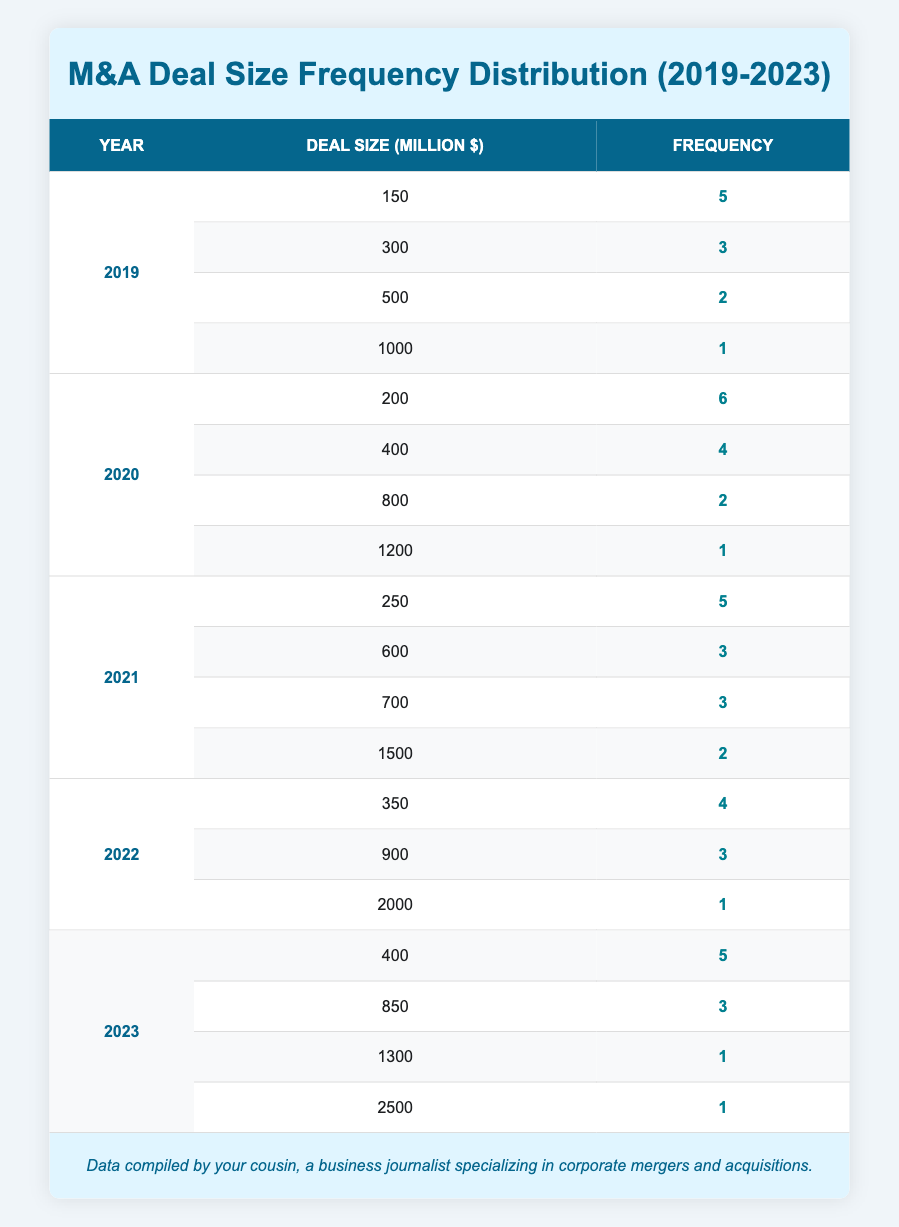What is the total number of M&A transactions in 2019? To find the total number of transactions in 2019, we need to add the counts for each deal size listed for that year. The counts are 5, 3, 2, and 1. So, 5 + 3 + 2 + 1 equals 11.
Answer: 11 Which year had the highest number of M&A transactions? By inspecting the table, we see that 2020 has counts of 6, 4, 2, and 1, summing to 13, while other years have lower totals. Therefore, 2020 had the highest number of transactions.
Answer: 2020 What deal size had the highest frequency in 2021? In 2021, the deal sizes with counts are 5, 3, 3, and 2. The highest frequency is 5, which corresponds to a deal size of 250 million.
Answer: 250 million Is there any deal size in 2022 that had a frequency of 5? Looking at the counts for 2022, we see the frequencies are 4, 3, and 1, so there is no deal size with a frequency of 5.
Answer: No What is the average deal size for all transactions in 2020? To calculate the average deal size for 2020, we take the deal sizes (200, 400, 800, 1200) and multiply each by their respective counts (6, 4, 2, 1). The total sum is (200*6 + 400*4 + 800*2 + 1200*1) = 1200 + 1600 + 1600 + 1200 = 5600. The total number of transactions in 2020 is 13. Thus, the average is 5600 divided by 13, which is approximately 430.77.
Answer: Approximately 430.77 What is the total frequency of transactions for deals above 1000 million dollars across all years? To find this, we look for deal sizes greater than 1000 million across all years. The only sizes are 1000, 1200, 1500, 2000, 1300, and 2500. Their frequencies are 1, 1, 2, 1, 1, and 1 respectively. Adding these gives: 1 + 1 + 2 + 1 + 1 + 1 = 7.
Answer: 7 